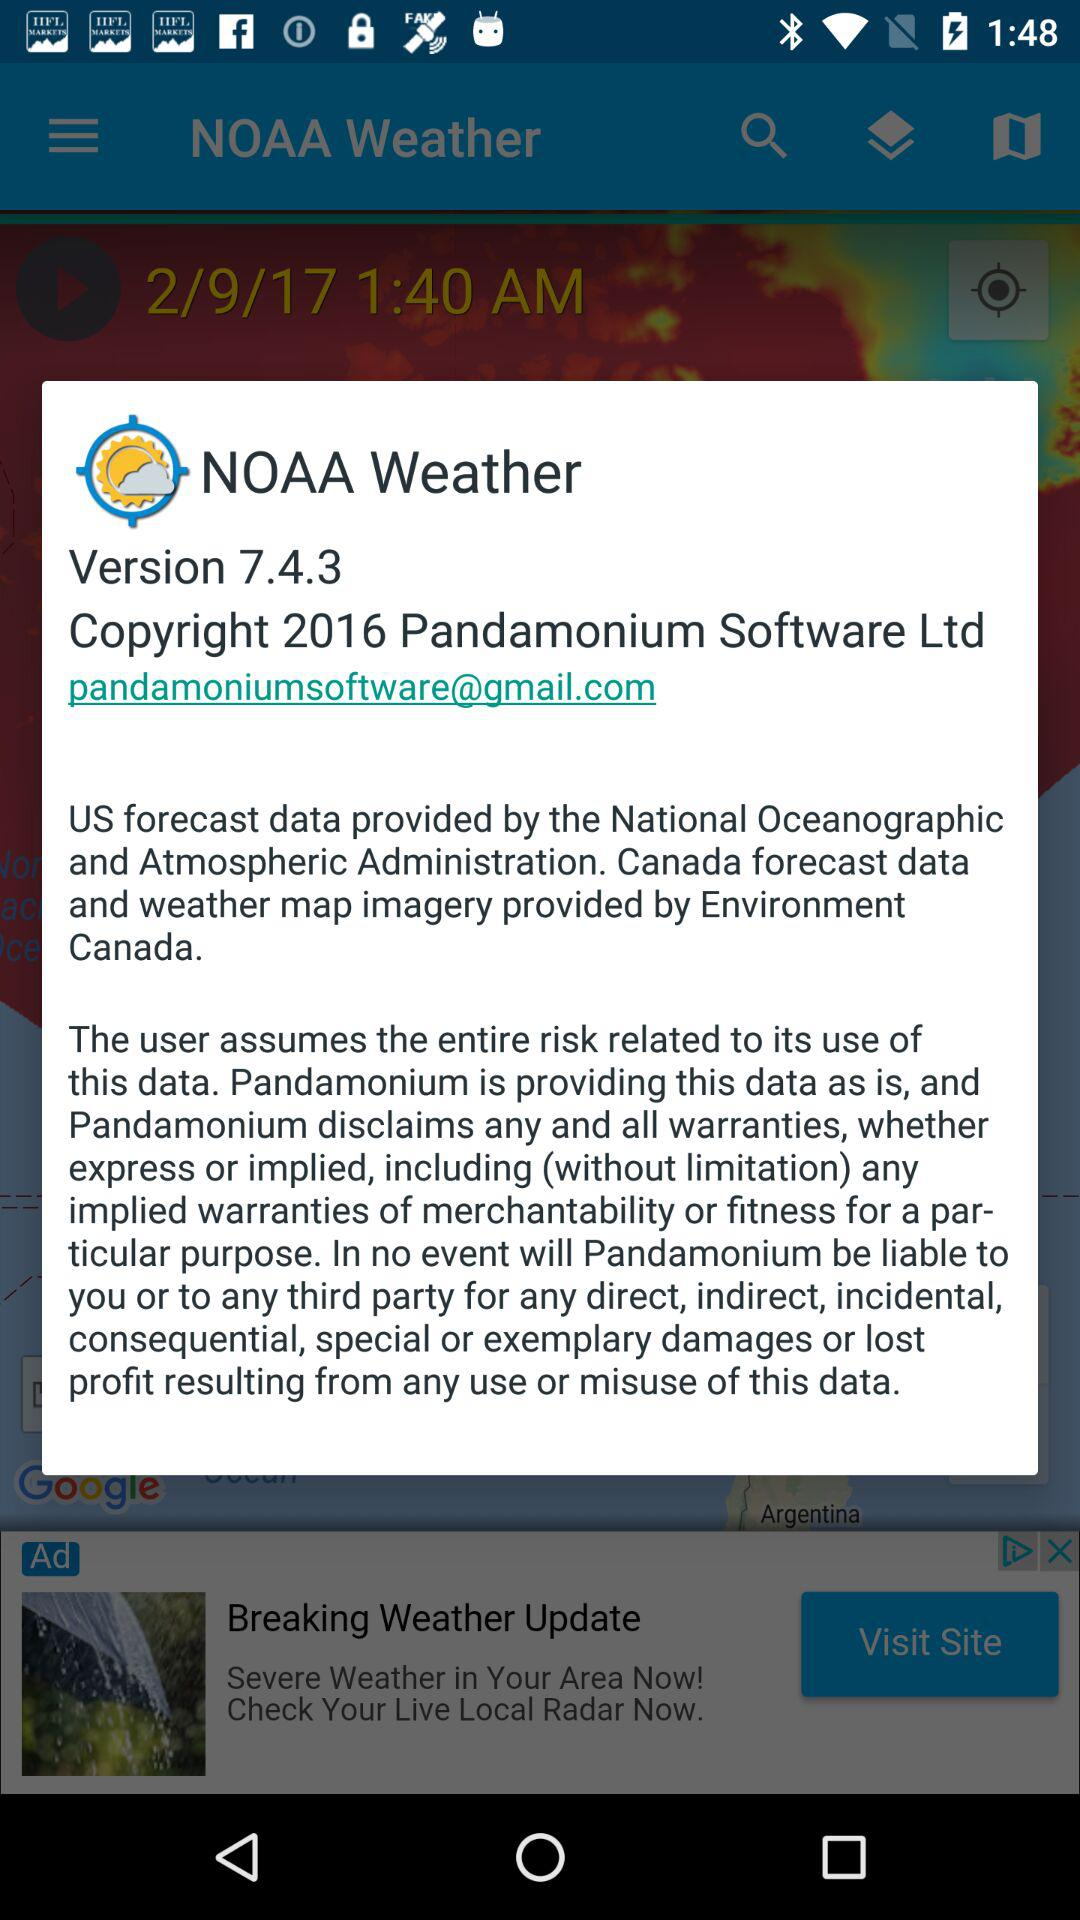Which continents are shown on the map?
When the provided information is insufficient, respond with <no answer>. <no answer> 